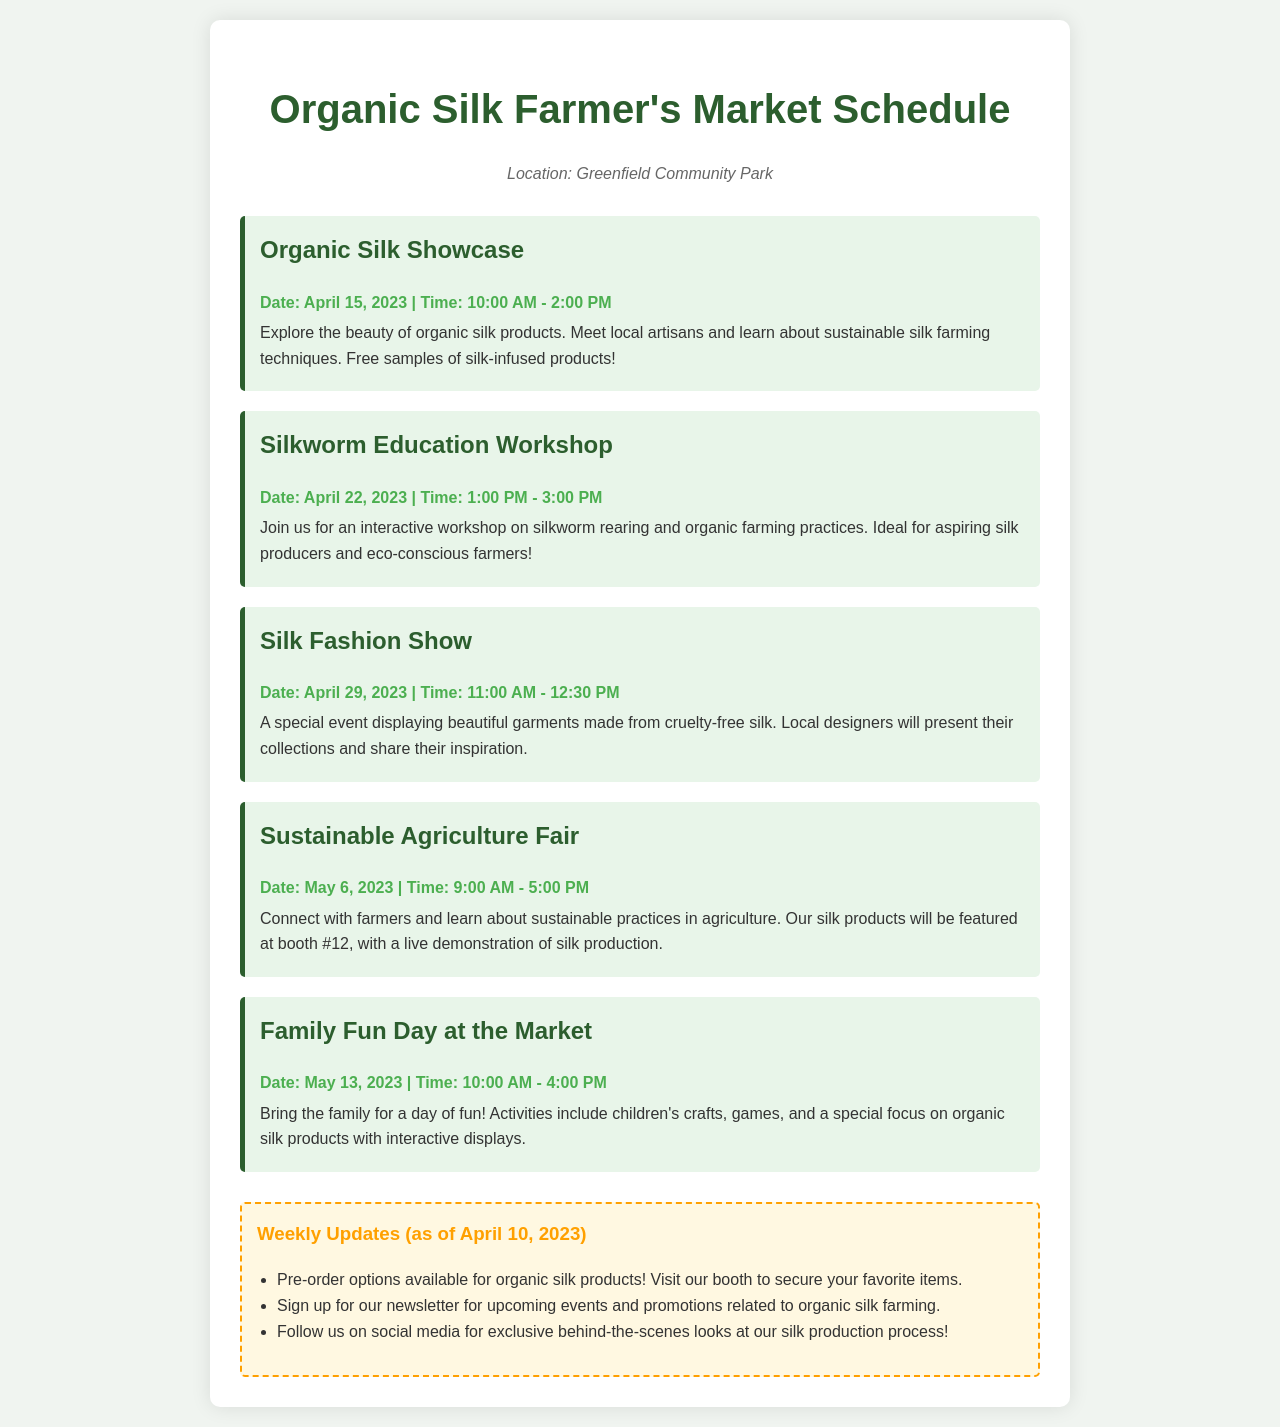What is the location of the market? The location is specifically mentioned in the document as "Greenfield Community Park."
Answer: Greenfield Community Park When is the Organic Silk Showcase scheduled? The document provides the date for the Organic Silk Showcase, which is stated clearly within the event details.
Answer: April 15, 2023 What time does the Silk Fashion Show start? The starting time for the Silk Fashion Show is detailed in the event section, indicating when attendees can expect it to begin.
Answer: 11:00 AM What type of event is scheduled on May 6, 2023? The nature of the event on May 6 is explicitly described, allowing for an understanding of what will take place on that date.
Answer: Sustainable Agriculture Fair How long is the Silkworm Education Workshop? The document specifies the duration of the Silkworm Education Workshop, making it clear how much time attendees should allocate.
Answer: 2 hours What activity will be featured during the Family Fun Day? The Family Fun Day's highlights include specific activities that are aimed at engaging participants, as outlined in the event description.
Answer: Children's crafts What is available for pre-order? The document mentions specific products available for pre-order, indicating what customers can reserve in advance.
Answer: Organic silk products What will be demonstrated at booth #12 during the Sustainable Agriculture Fair? The document indicates a specific demonstration that will occur at a designated booth during the fair, referencing the silk production process.
Answer: Live demonstration of silk production 